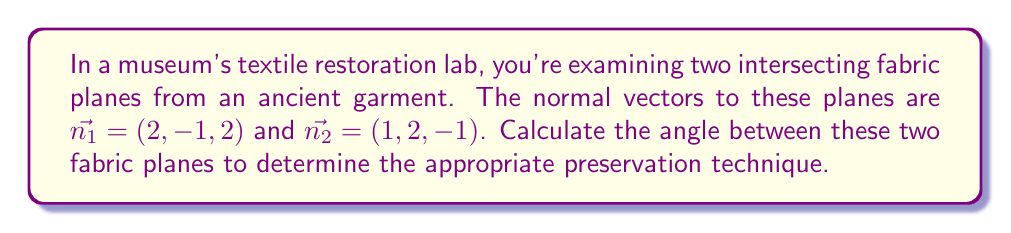Help me with this question. To find the angle between two intersecting planes, we can use the angle between their normal vectors. The process is as follows:

1) The formula for the angle $\theta$ between two vectors $\vec{a}$ and $\vec{b}$ is:

   $$\cos \theta = \frac{\vec{a} \cdot \vec{b}}{|\vec{a}||\vec{b}|}$$

2) In our case, $\vec{a} = \vec{n_1} = (2, -1, 2)$ and $\vec{b} = \vec{n_2} = (1, 2, -1)$

3) Calculate the dot product $\vec{n_1} \cdot \vec{n_2}$:
   $$(2)(1) + (-1)(2) + (2)(-1) = 2 - 2 - 2 = -2$$

4) Calculate $|\vec{n_1}|$:
   $$|\vec{n_1}| = \sqrt{2^2 + (-1)^2 + 2^2} = \sqrt{4 + 1 + 4} = \sqrt{9} = 3$$

5) Calculate $|\vec{n_2}|$:
   $$|\vec{n_2}| = \sqrt{1^2 + 2^2 + (-1)^2} = \sqrt{1 + 4 + 1} = \sqrt{6}$$

6) Substitute into the formula:

   $$\cos \theta = \frac{-2}{3\sqrt{6}}$$

7) Take the inverse cosine (arccos) of both sides:

   $$\theta = \arccos\left(\frac{-2}{3\sqrt{6}}\right)$$

8) Calculate the result (in radians), then convert to degrees:

   $$\theta \approx 2.0344 \text{ radians} \approx 116.57°$$
Answer: The angle between the two fabric planes is approximately 116.57°. 